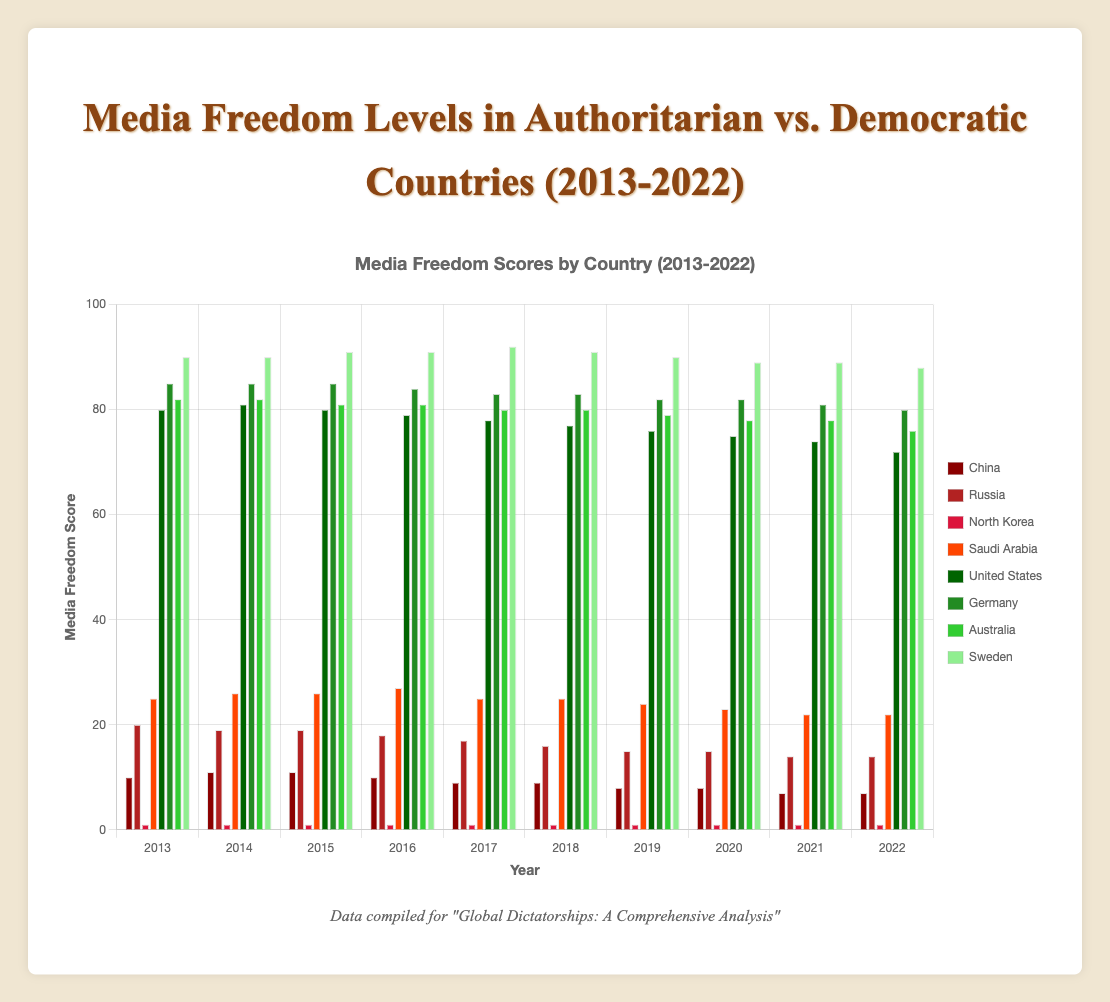How has media freedom changed in Russia from 2013 to 2022? Compare the height of the bars for Russia from the year 2013 to 2022. The media freedom score in Russia decreased from 20 in 2013 to 14 in 2022.
Answer: Decreased from 20 to 14 Which democratic country has the highest media freedom score in 2022? Look at the bars for all democratic countries in 2022 and compare their heights. Sweden has the highest score with 88 in 2022.
Answer: Sweden with a score of 88 Compare the media freedom scores of China and the United States in 2016. Which country had a higher score? Find the bars for China and the United States in 2016. The United States scored 79, while China scored 10. The United States had a higher score.
Answer: United States What is the average media freedom score for North Korea over the last 10 years? Sum the scores for North Korea over the 10 years (1*10) and divide by 10. The sum is 10, so the average is 10/10 = 1.
Answer: 1 Which country showed the most improvement in media freedom score among authoritarian regimes from 2013 to 2022? Calculate the difference in media freedom scores from 2013 to 2022 for each authoritarian regime. China improved from 10 to 7, a difference of +3. Russia improved from 20 to 14, a difference of +6. North Korea remained constant at 1. Saudi Arabia declined from 25 to 22. Russia showed the most improvement.
Answer: Russia What is the sum of media freedom scores for Saudi Arabia in 2017 and 2018? Add the scores of Saudi Arabia for the years 2017 and 2018: 25 + 25 = 50.
Answer: 50 How does the media freedom trend in Germany compare to that in Australia from 2013 to 2022? Observe the trends in the bars for Germany and Australia. Germany's scores slightly decreased from 85 to 80, while Australia also saw a similar decline from 82 to 76. Both countries show a gradual downward trend, with Australia experiencing a slightly larger decline.
Answer: Both declined, Australia more Which authoritarian country had consistently the lowest media freedom score over the last 10 years? Look at the bars for each authoritarian country over the 10 years to find the lowest constant value. North Korea had a constant score of 1 throughout the period.
Answer: North Korea Calculate the average media freedom score for all democratic countries in the year 2020. Sum the scores for democratic countries in 2020 and divide by the number of countries (United States: 75, Germany: 82, Australia: 78, Sweden: 89). Average = (75 + 82 + 78 + 89) / 4 = 324 / 4 = 81.
Answer: 81 What is the largest difference in media freedom scores between any two countries in 2022? Compare the scores for all countries in 2022 to find the largest difference. The largest difference is between Sweden (88) and North Korea (1), which is 88 - 1 = 87.
Answer: 87 